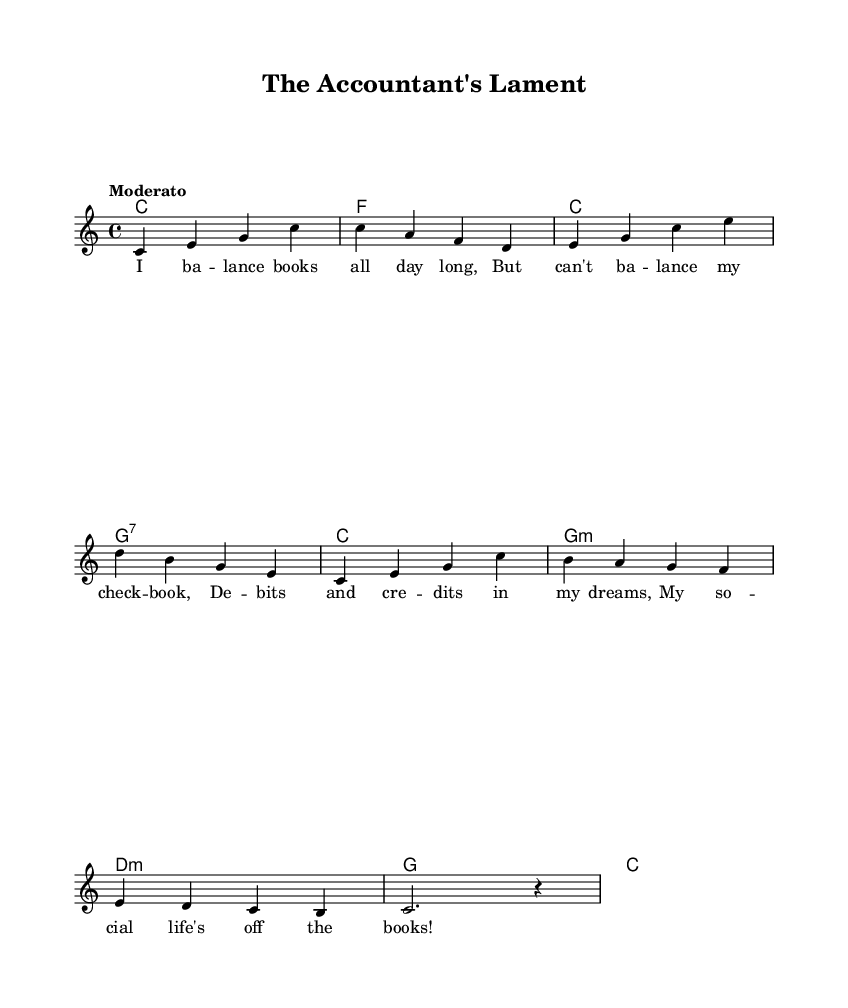What is the key signature of this music? The key signature is C major, indicated by the absence of sharps or flats at the beginning of the staff.
Answer: C major What is the time signature of the piece? The time signature is found at the beginning of the staff and is indicated as 4/4, which means there are four beats in a measure and the quarter note gets one beat.
Answer: 4/4 What is the tempo marking for this composition? The tempo marking "Moderato" is noted at the beginning of the score, indicating a moderate speed.
Answer: Moderato How many measures are in the melody? The melody consists of a total of eight measures, which can be counted visually by looking at the number of vertical lines separating the groups of notes.
Answer: Eight What is the first chord of the harmony? The first chord in the harmony section is noted as C in the chord symbols directly below the staff.
Answer: C Which lyric corresponds to the second measure of the melody? The lyrics for the second measure are "But can't ba -- lance my check -- book," which can be matched with the notes in that measure.
Answer: But can't ba -- lance my check -- book What humorous theme is presented in the lyrics? The lyrics present a humorous reflection on accounting, specifically the struggles of balancing books, which adds lightheartedness and wordplay typical of comedic novelty songs.
Answer: Balancing books 